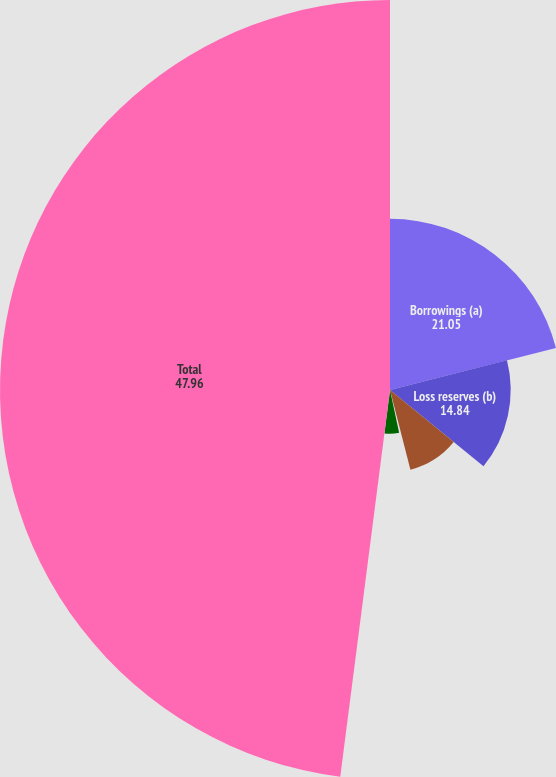Convert chart to OTSL. <chart><loc_0><loc_0><loc_500><loc_500><pie_chart><fcel>Borrowings (a)<fcel>Loss reserves (b)<fcel>Insurance and investment<fcel>Operating leases<fcel>Aircraft purchase commitments<fcel>Total<nl><fcel>21.05%<fcel>14.84%<fcel>10.11%<fcel>0.65%<fcel>5.38%<fcel>47.96%<nl></chart> 